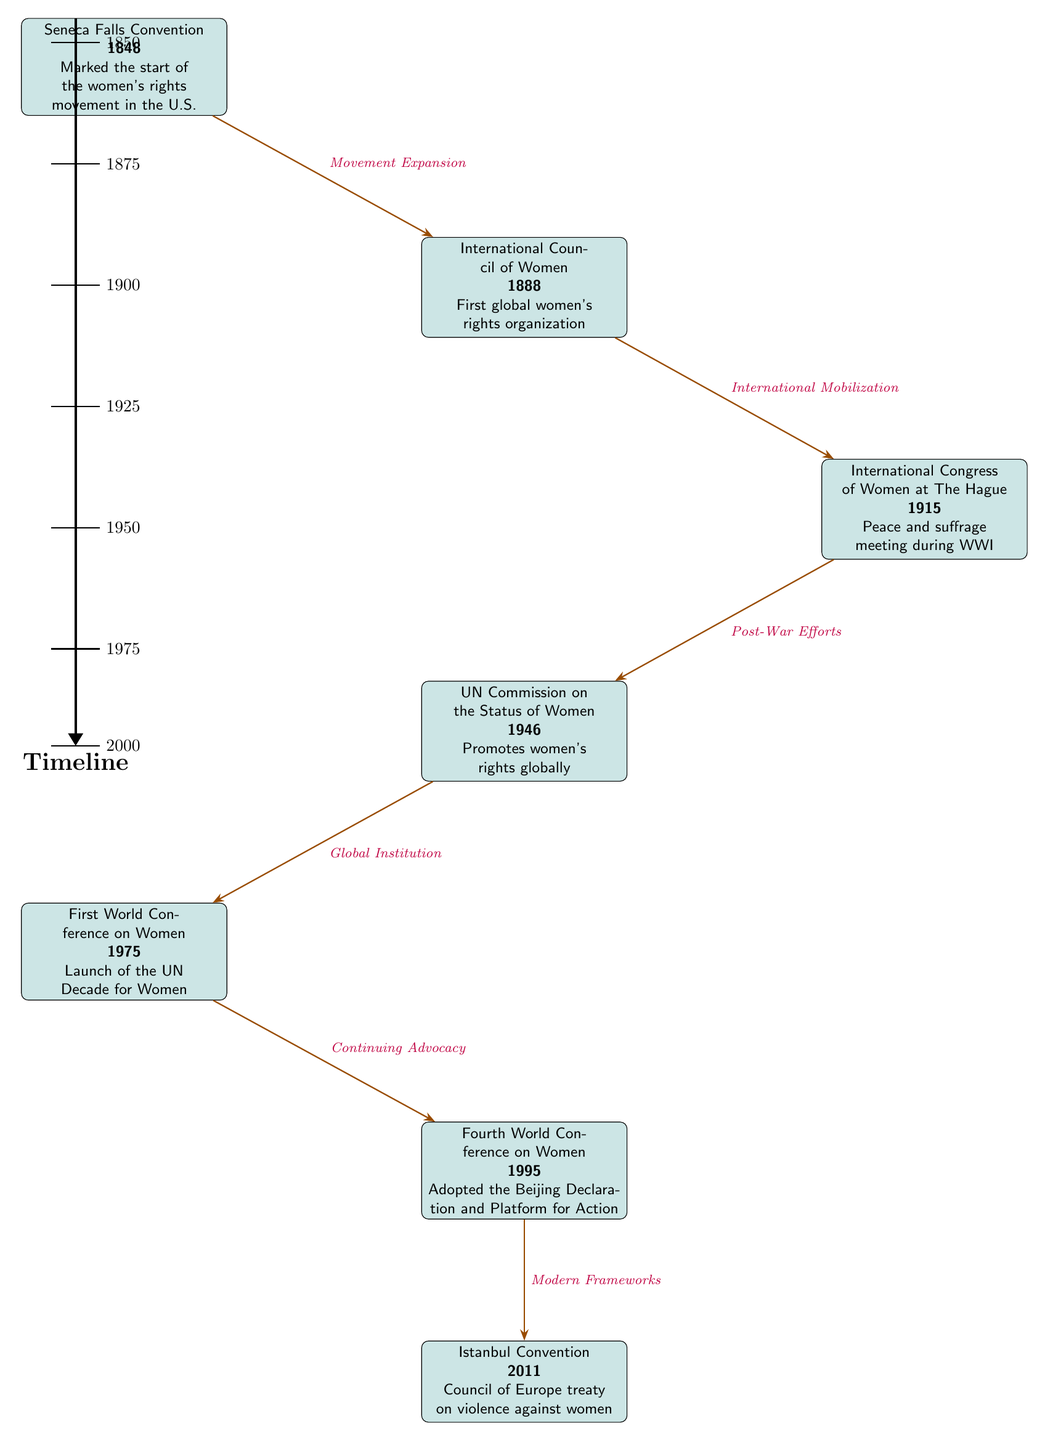What year did the Seneca Falls Convention take place? The diagram indicates that the Seneca Falls Convention occurred in the year 1848, as it is specifically mentioned below the event node for that convention.
Answer: 1848 What is the primary focus of the International Council of Women established in 1888? The diagram states that the International Council of Women was the "First global women's rights organization," indicating its foundational role in women's rights.
Answer: First global women's rights organization How many major events are represented in the diagram? By counting each of the nodes representing different conventions and conferences, there are six distinct events displayed in the timeline.
Answer: 6 Which event directly follows the International Congress of Women at The Hague in the timeline? According to the arrow movement in the diagram, the event that directly follows the International Congress of Women at The Hague is the "UN Commission on the Status of Women" in 1946.
Answer: UN Commission on the Status of Women What is the relationship defined between the Istanbul Convention and the Fourth World Conference on Women? The arrow drawn between the Fourth World Conference on Women (1995) and the Istanbul Convention (2011) describes the relationship as "Modern Frameworks." This indicates that the conference contributed to frameworks that influenced the Istanbul Convention.
Answer: Modern Frameworks What significant occurrence began with the First World Conference on Women in 1975? The diagram notes that the First World Conference on Women marked the "Launch of the UN Decade for Women," highlighting its importance in promoting women’s issues globally.
Answer: Launch of the UN Decade for Women Which event occurred closest to the year 2000 based on the timeline? The diagram lists the events chronologically, with the Istanbul Convention in 2011 being the last event positioned below the timeline. Therefore, the closest event to the year 2000 is the Fourth World Conference on Women, which took place in 1995.
Answer: Fourth World Conference on Women What major theme connects the events from the Seneca Falls Convention to the Fourth World Conference on Women? The events can be seen to connect through their overarching theme of "Women's Rights Movement," as each event builds upon previous efforts towards women's rights. This theme is implicit in the progression shown in the diagram.
Answer: Women's Rights Movement 